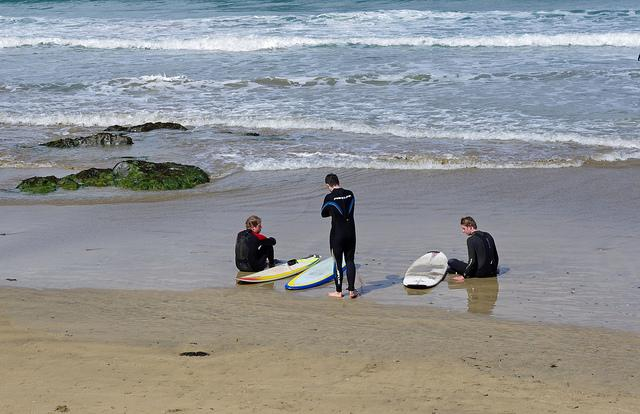What is the green substance near the shoreline? Please explain your reasoning. moss. This is a moss that grows in wet area because of water. 